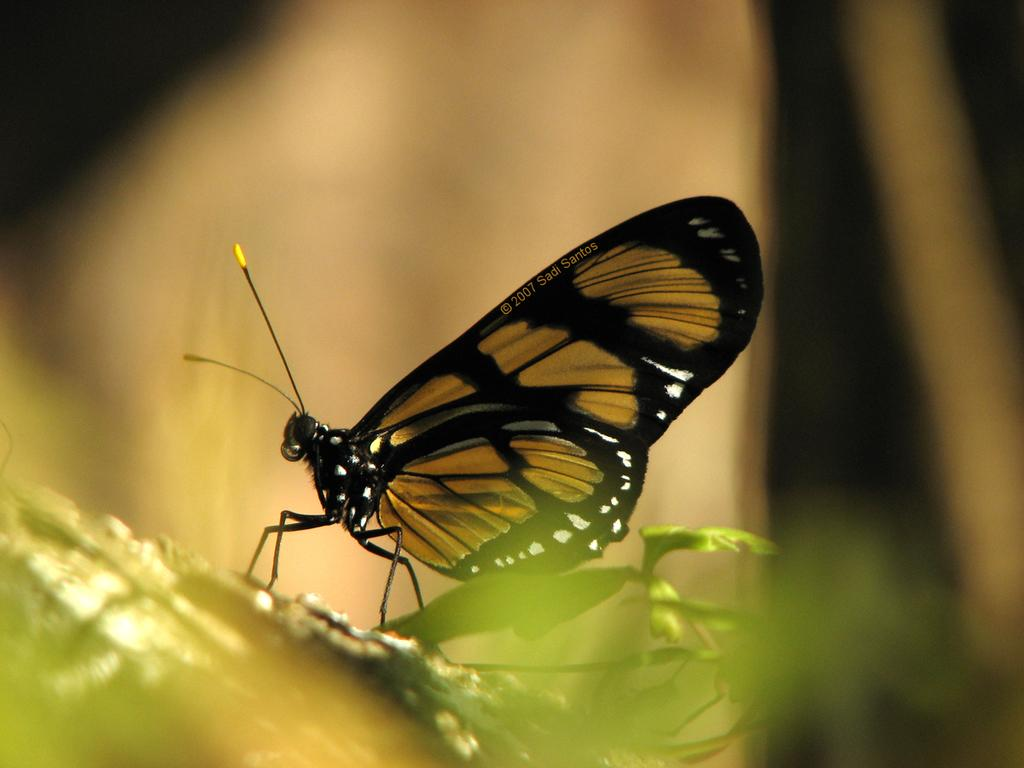What type of insect is featured in the image? The image features a butterfly. Can you describe the appearance of the butterfly? The butterfly is beautiful and has brown and black colors. What type of paste is used to cover the butterfly's wings in the image? There is no paste or covering mentioned in the image; the butterfly's wings are naturally colored with brown and black. 